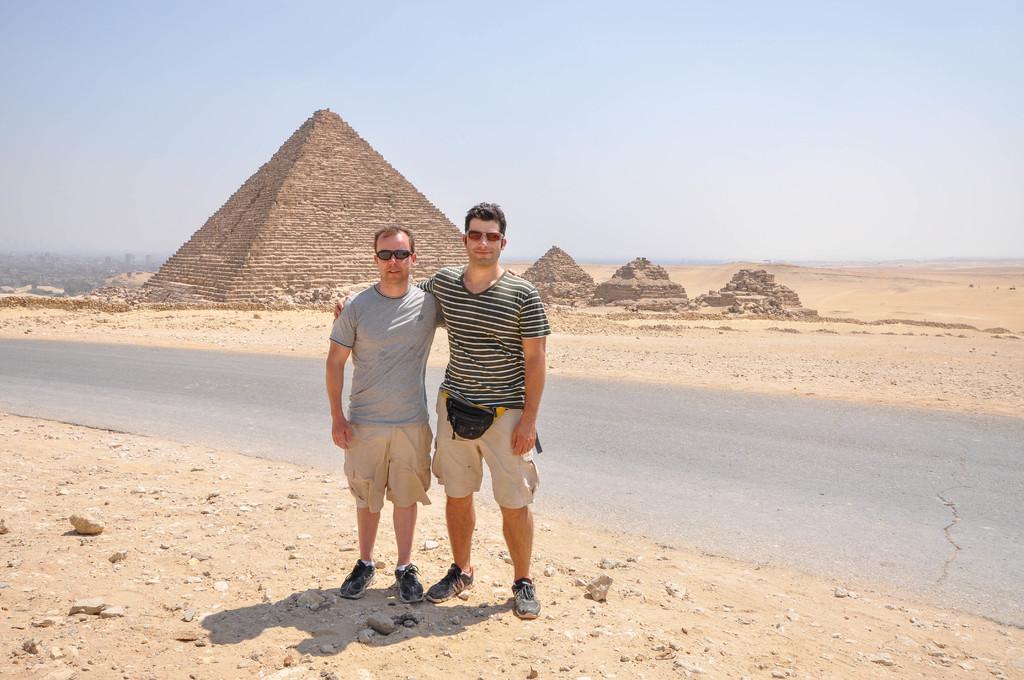Please provide a concise description of this image. In the center of the image we can see men on the ground. In the background we can see road, pyramids, sand and sky. 